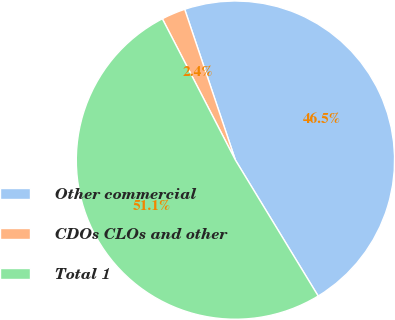Convert chart to OTSL. <chart><loc_0><loc_0><loc_500><loc_500><pie_chart><fcel>Other commercial<fcel>CDOs CLOs and other<fcel>Total 1<nl><fcel>46.46%<fcel>2.43%<fcel>51.11%<nl></chart> 